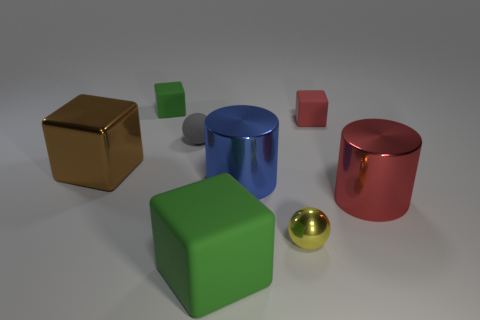How many green blocks must be subtracted to get 1 green blocks? 1 Add 1 big red shiny balls. How many objects exist? 9 Subtract all spheres. How many objects are left? 6 Add 2 shiny blocks. How many shiny blocks are left? 3 Add 6 cyan rubber cylinders. How many cyan rubber cylinders exist? 6 Subtract 0 cyan cylinders. How many objects are left? 8 Subtract all small matte balls. Subtract all brown blocks. How many objects are left? 6 